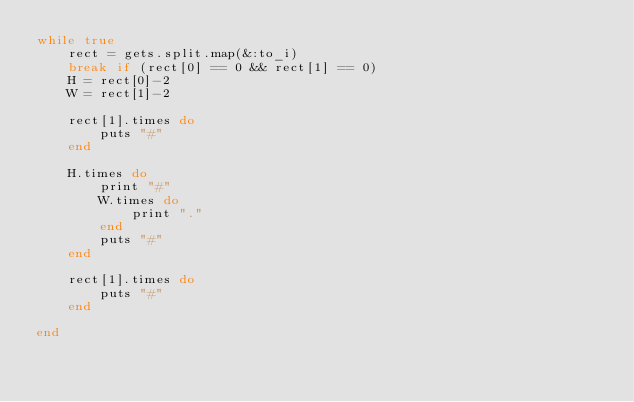Convert code to text. <code><loc_0><loc_0><loc_500><loc_500><_Ruby_>while true
    rect = gets.split.map(&:to_i)
    break if (rect[0] == 0 && rect[1] == 0)
    H = rect[0]-2
    W = rect[1]-2
    
    rect[1].times do
        puts "#"
    end
    
    H.times do
        print "#"
        W.times do
            print "."
        end
        puts "#"
    end
    
    rect[1].times do
        puts "#"
    end
    
end</code> 